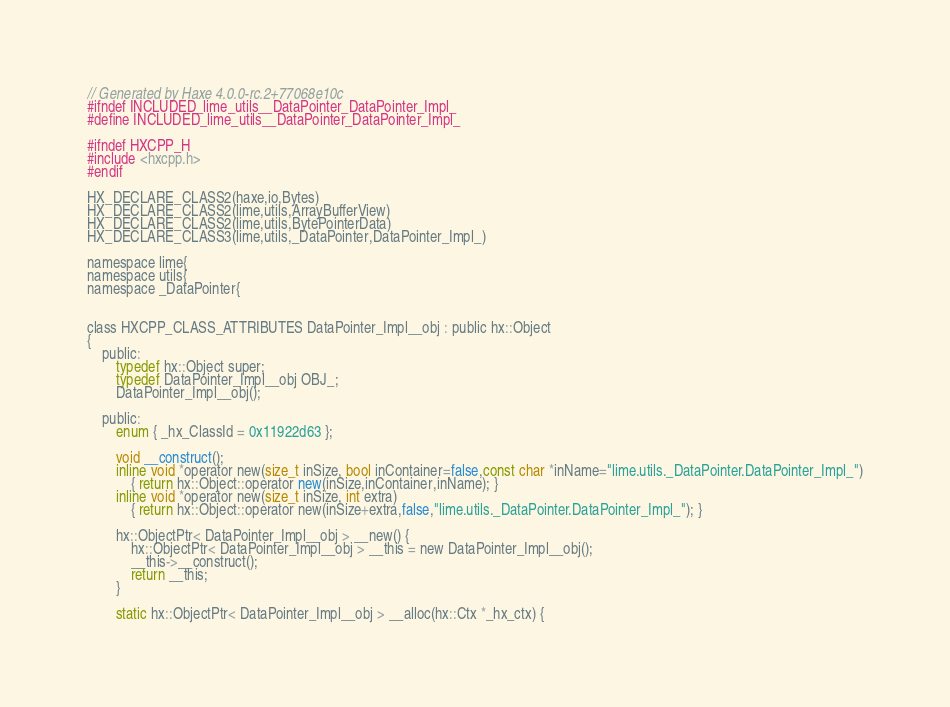<code> <loc_0><loc_0><loc_500><loc_500><_C_>// Generated by Haxe 4.0.0-rc.2+77068e10c
#ifndef INCLUDED_lime_utils__DataPointer_DataPointer_Impl_
#define INCLUDED_lime_utils__DataPointer_DataPointer_Impl_

#ifndef HXCPP_H
#include <hxcpp.h>
#endif

HX_DECLARE_CLASS2(haxe,io,Bytes)
HX_DECLARE_CLASS2(lime,utils,ArrayBufferView)
HX_DECLARE_CLASS2(lime,utils,BytePointerData)
HX_DECLARE_CLASS3(lime,utils,_DataPointer,DataPointer_Impl_)

namespace lime{
namespace utils{
namespace _DataPointer{


class HXCPP_CLASS_ATTRIBUTES DataPointer_Impl__obj : public hx::Object
{
	public:
		typedef hx::Object super;
		typedef DataPointer_Impl__obj OBJ_;
		DataPointer_Impl__obj();

	public:
		enum { _hx_ClassId = 0x11922d63 };

		void __construct();
		inline void *operator new(size_t inSize, bool inContainer=false,const char *inName="lime.utils._DataPointer.DataPointer_Impl_")
			{ return hx::Object::operator new(inSize,inContainer,inName); }
		inline void *operator new(size_t inSize, int extra)
			{ return hx::Object::operator new(inSize+extra,false,"lime.utils._DataPointer.DataPointer_Impl_"); }

		hx::ObjectPtr< DataPointer_Impl__obj > __new() {
			hx::ObjectPtr< DataPointer_Impl__obj > __this = new DataPointer_Impl__obj();
			__this->__construct();
			return __this;
		}

		static hx::ObjectPtr< DataPointer_Impl__obj > __alloc(hx::Ctx *_hx_ctx) {</code> 